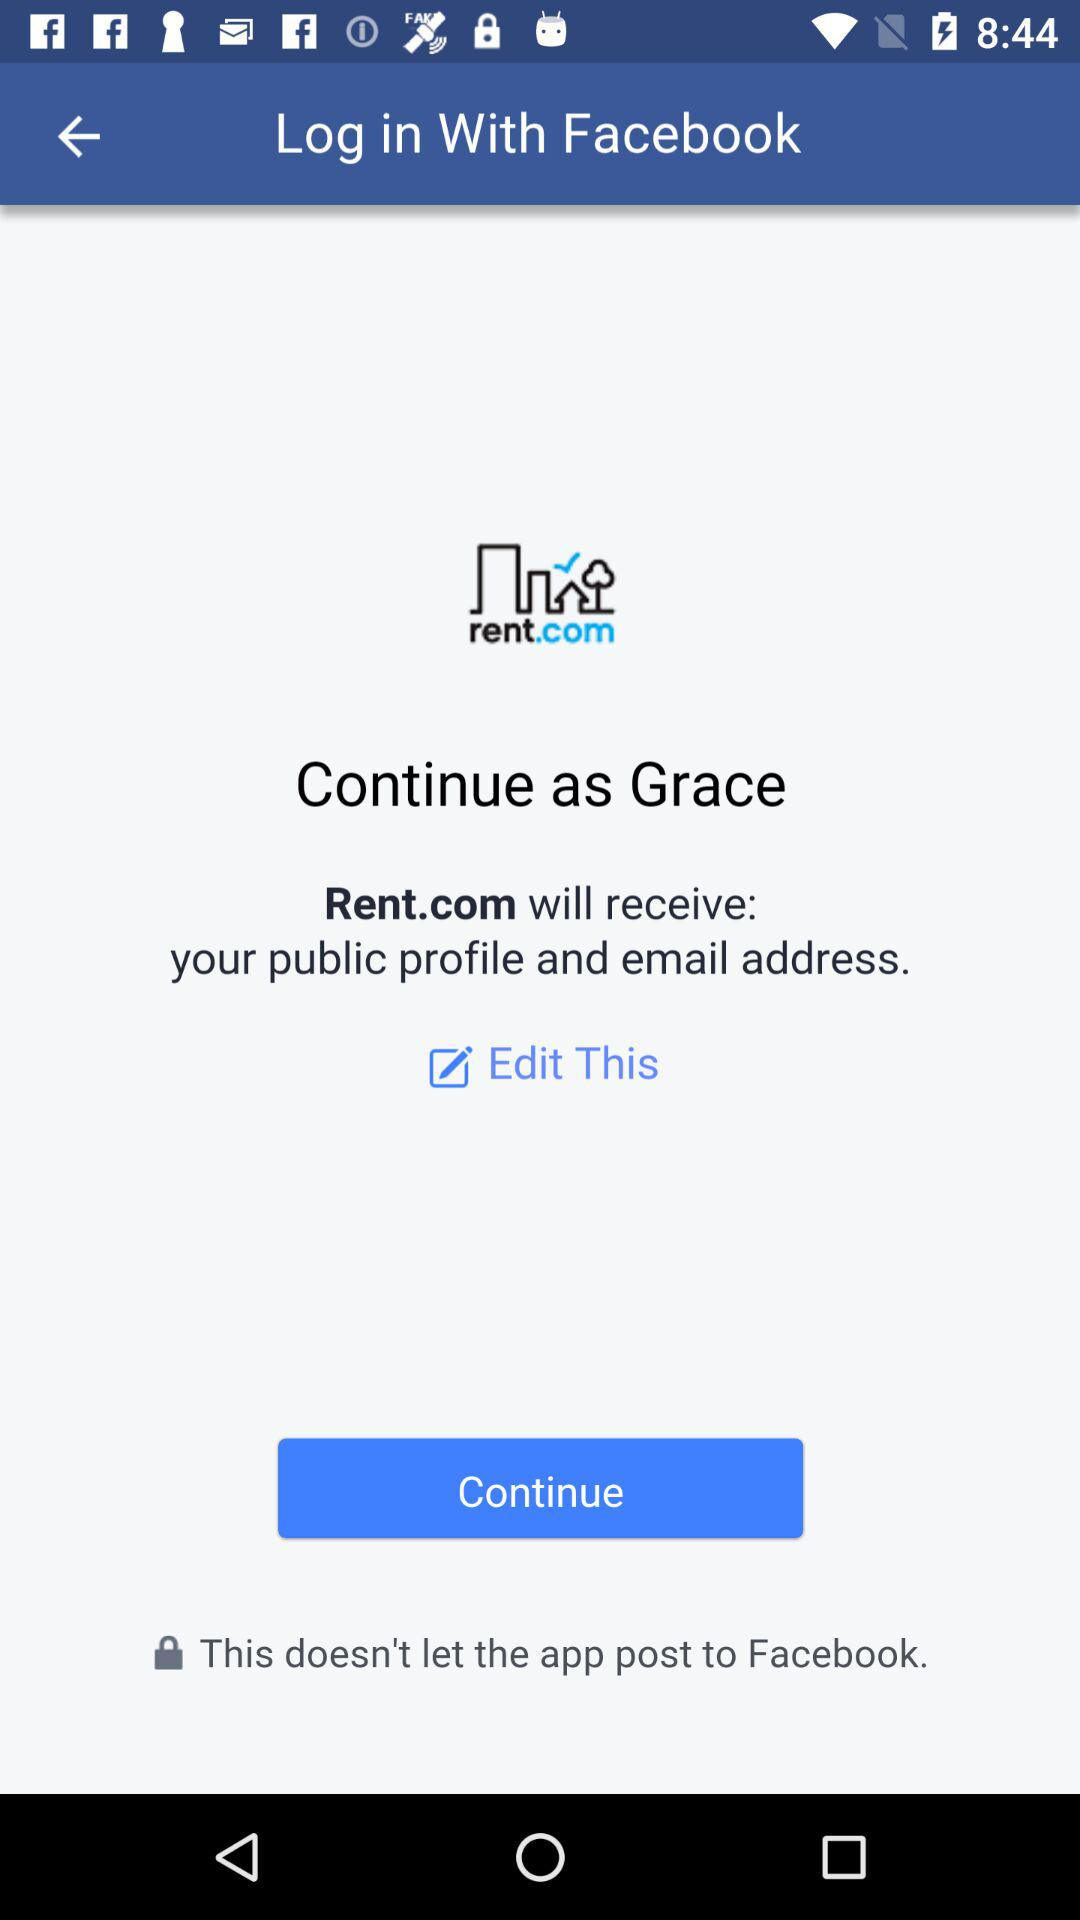What application is asking for permission? The application that is asking for permission is "Rent.com". 